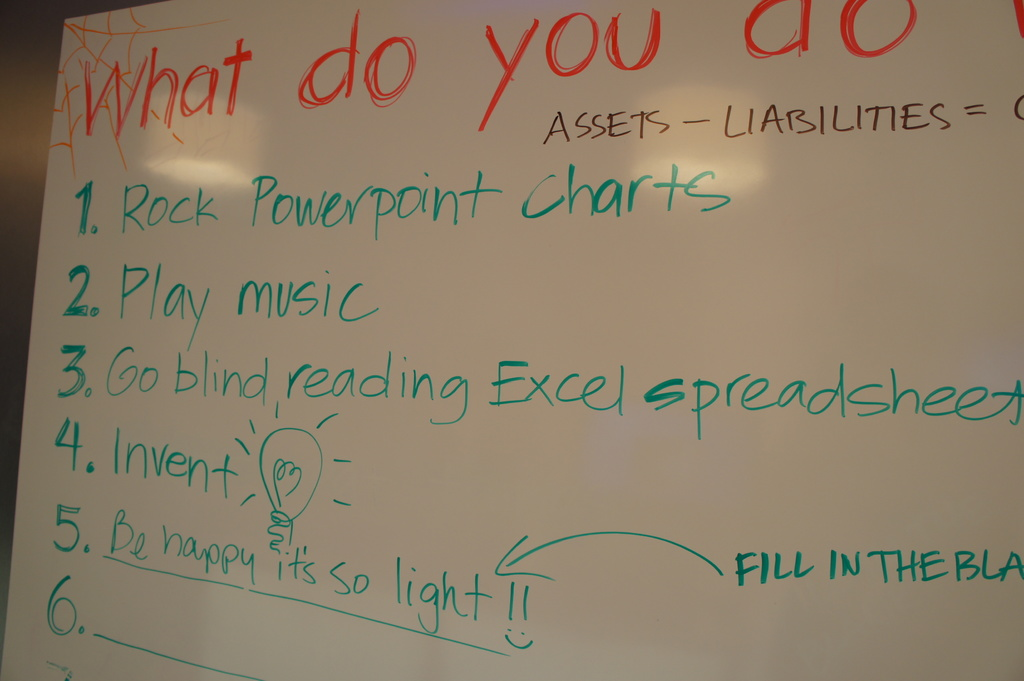What innovative ideas could be suggested to fill the blank space labeled 'FILL IN THE BLANK' on the whiteboard? To fill the blank space on the whiteboard, consider suggesting 'Utilize AI for forecasting.' This involves leveraging artificial intelligence to analyze past financial data and predict future trends, thereby providing invaluable insights for managing assets, liabilities, and equity more effectively. This approach fits the innovative and forward-thinking theme displayed on the board. 